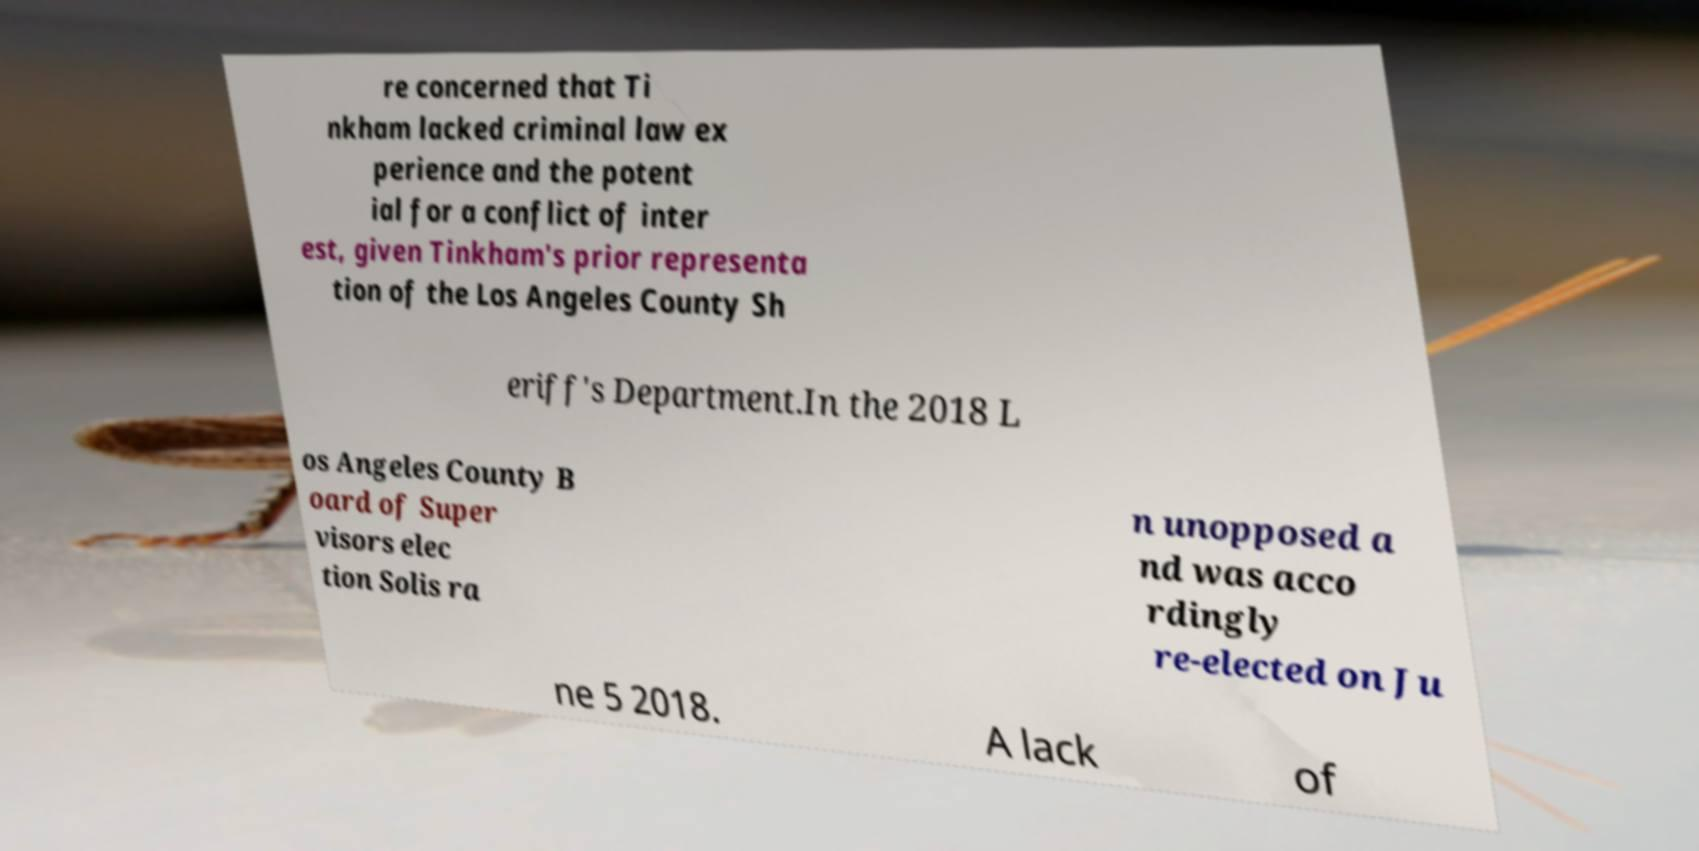I need the written content from this picture converted into text. Can you do that? re concerned that Ti nkham lacked criminal law ex perience and the potent ial for a conflict of inter est, given Tinkham's prior representa tion of the Los Angeles County Sh eriff's Department.In the 2018 L os Angeles County B oard of Super visors elec tion Solis ra n unopposed a nd was acco rdingly re-elected on Ju ne 5 2018. A lack of 